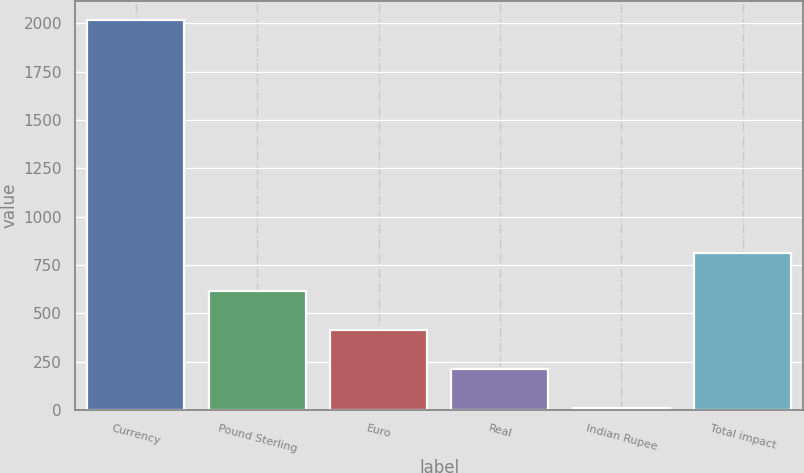Convert chart. <chart><loc_0><loc_0><loc_500><loc_500><bar_chart><fcel>Currency<fcel>Pound Sterling<fcel>Euro<fcel>Real<fcel>Indian Rupee<fcel>Total impact<nl><fcel>2016<fcel>613.2<fcel>412.8<fcel>212.4<fcel>12<fcel>813.6<nl></chart> 